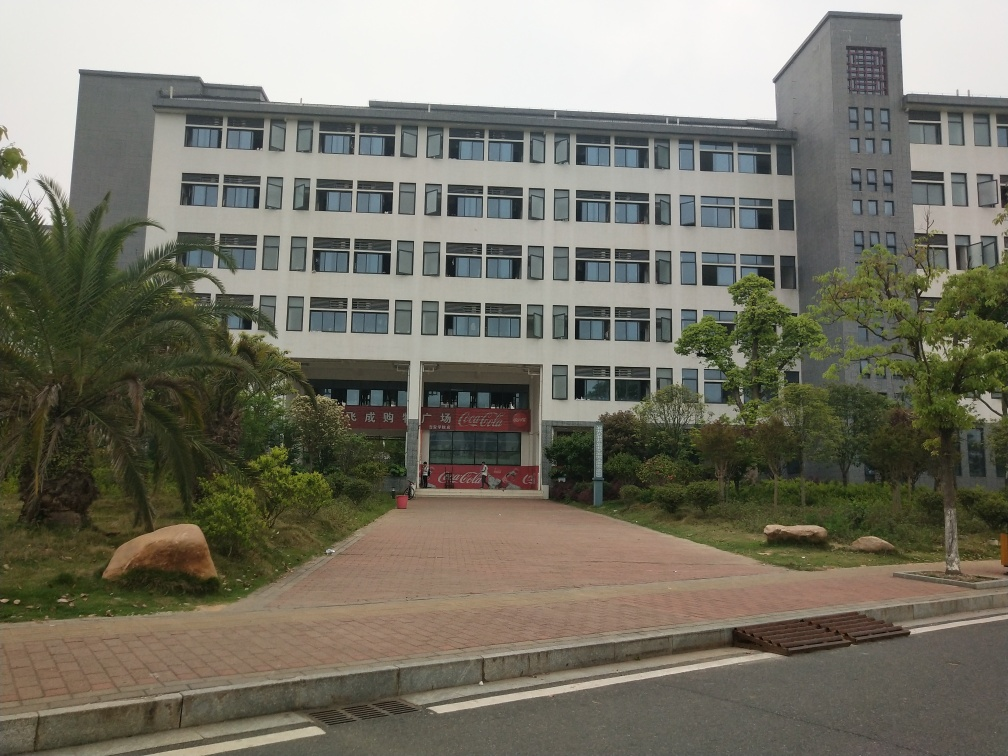What can be said about the overall color of the image? The image predominantly features neutral tones of gray in the building structure, complemented by greenery from the plants and trees surrounding the area, and a reddish-brown from the bricks on the ground. The colors suggest a practical and functional space, typically associated with institutional or corporate buildings. 